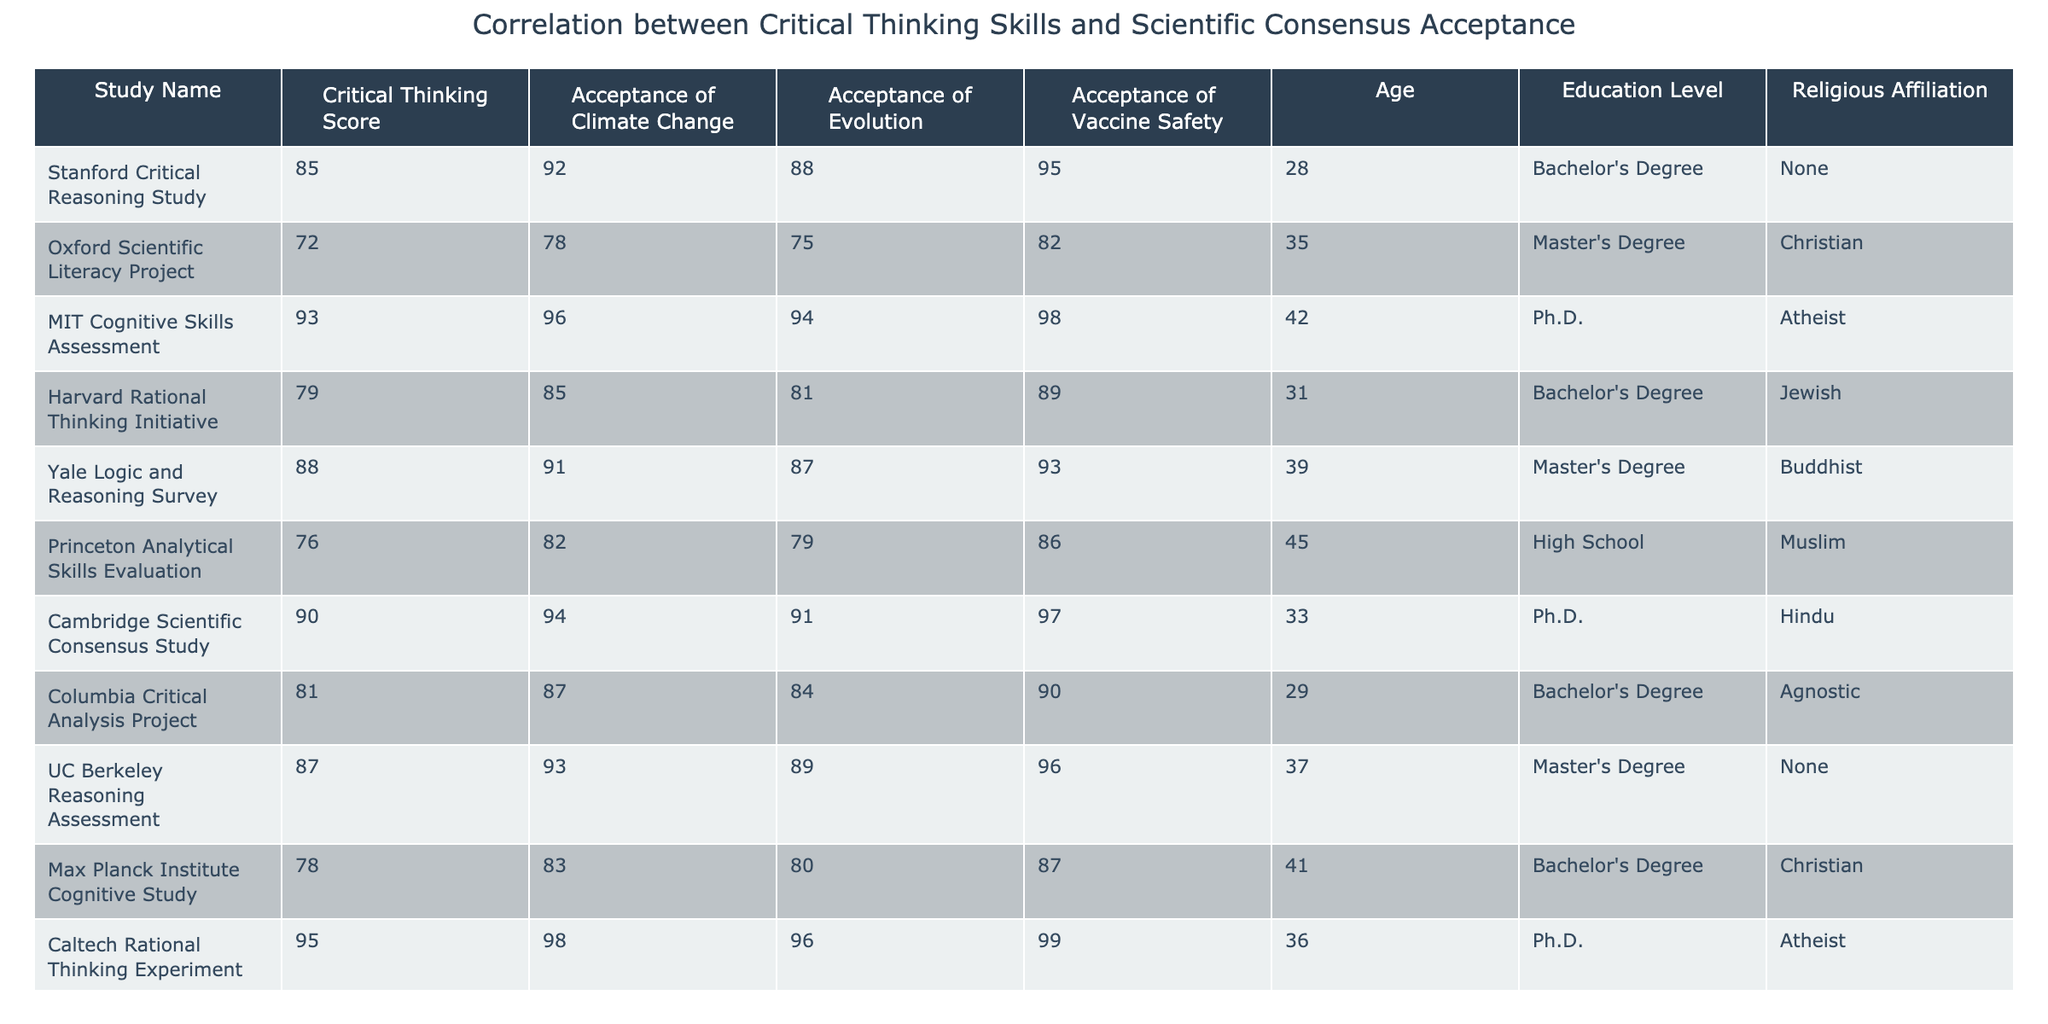What is the critical thinking score of the study with the highest acceptance of vaccine safety? By reviewing the table, the study with the highest acceptance of vaccine safety is the "Caltech Rational Thinking Experiment" with a score of 95.
Answer: 95 Which study has the lowest acceptance of climate change? The study with the lowest acceptance of climate change is the "Max Planck Institute Cognitive Study," where the acceptance score is 83.
Answer: 83 What is the average critical thinking score for studies with a religious affiliation of 'Atheist'? The studies with 'Atheist' affiliations are "MIT Cognitive Skills Assessment" (93) and "Caltech Rational Thinking Experiment" (95). Adding them gives 93 + 95 = 188, and dividing by 2 gives an average of 94.
Answer: 94 Is there a correlation between higher critical thinking scores and acceptance of evolution? To assess this, we observe that the studies with the three highest critical thinking scores (Caltech, MIT, and Cambridge) also have acceptance scores of 96, 94, and 91 for evolution, respectively, suggesting a positive correlation.
Answer: Yes What is the highest acceptance score of climate change and which study achieved it? The highest acceptance score for climate change is 98, achieved by the "Caltech Rational Thinking Experiment."
Answer: 98, Caltech Rational Thinking Experiment Identify the difference in critical thinking scores between the oldest and youngest participants in the studies. The oldest participant (45 years) is in the "Princeton Analytical Skills Evaluation" with a score of 76, while the youngest participant (28 years) is in the "Stanford Critical Reasoning Study" with a score of 85. The difference is calculated as 85 - 76 = 9.
Answer: 9 How many studies show an acceptance of both climate change and evolution above 90? By looking at the table, five studies have acceptance scores for both criteria as follows: "Stanford Critical Reasoning Study" (92, 88), "MIT Cognitive Skills Assessment" (96, 94), "Caltech Rational Thinking Experiment" (98, 96), "Cambridge Scientific Consensus Study" (94, 91), and "UC Berkeley Reasoning Assessment" (93, 89). Thus, a total of five studies meet this criterion.
Answer: 5 What is the median critical thinking score for participants with a Bachelor's degree? The studies with a Bachelor's degree are "Stanford Critical Reasoning Study" (85), "Harvard Rational Thinking Initiative" (79), "Columbia Critical Analysis Project" (81), "Max Planck Institute Cognitive Study" (78), and "UCLA Scientific Literacy Evaluation" (74). Arranging these scores: 74, 78, 79, 81, 85, the median is the middle value, which is 79.
Answer: 79 Is there a noticeable trend in acceptance of scientific consensus among participants belonging to different religious affiliations? Reviewing the table, it appears that the acceptance of scientific consensus (i.e., climate change, evolution, vaccine safety) varies, with participants having no religious affiliation generally exhibiting higher acceptance scores compared to other religious affiliations. This suggests that there might be a trend where lower religious affiliation correlates with higher acceptance of scientific consensus.
Answer: Yes 